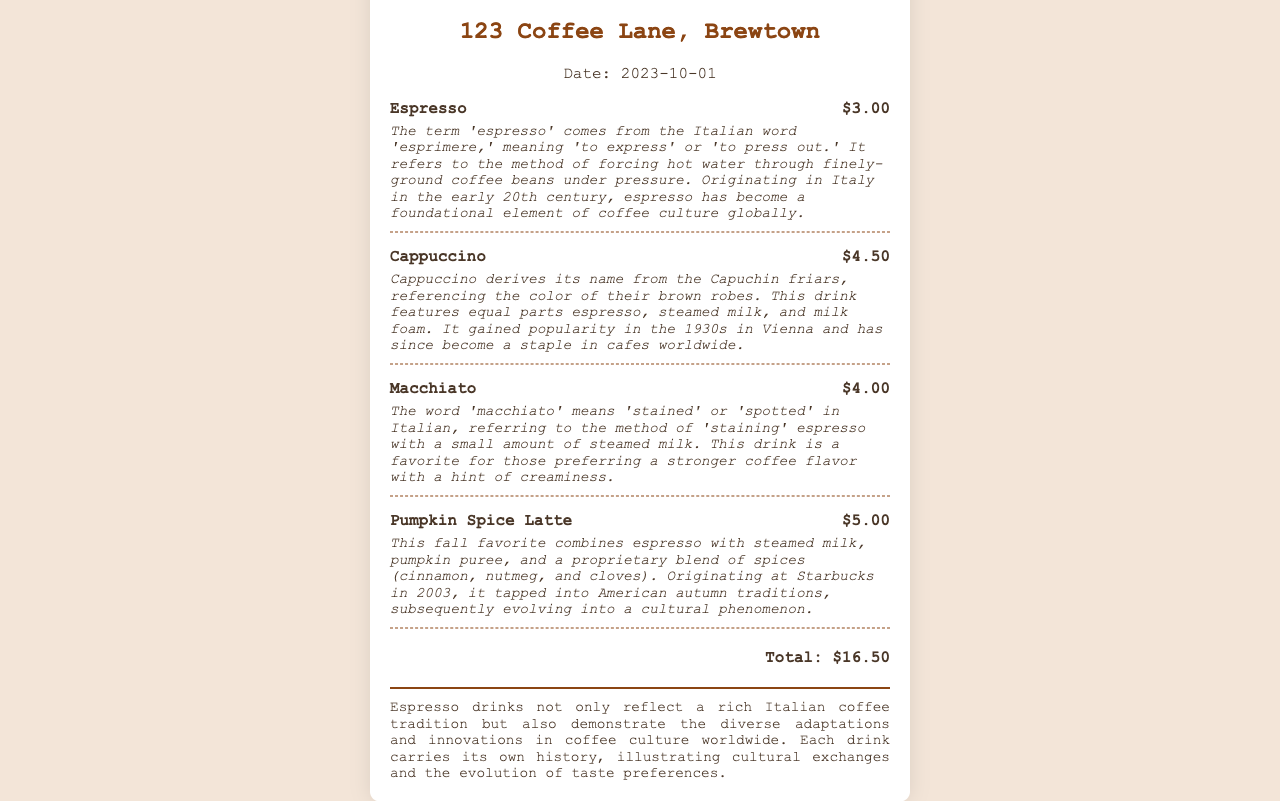What is the date of the receipt? The date of the receipt is clearly stated at the top of the document.
Answer: 2023-10-01 What is the total amount on the receipt? The total amount is summarized at the bottom of the receipt.
Answer: $16.50 What drink comes from the Italian word meaning 'to express'? The origin of the word is provided within the description of the drink.
Answer: Espresso Which drink is named after Capuchin friars? The cultural reference is explained in the item's description.
Answer: Cappuccino How much does a Pumpkin Spice Latte cost? The prices are listed next to each item in the receipt.
Answer: $5.00 What does 'macchiato' mean in Italian? The meaning is explained in the description of the macchiato drink.
Answer: Stained In which decade did the Cappuccino gain popularity? The information is found in the drink's origin history on the receipt.
Answer: 1930s What elements are combined in a Pumpkin Spice Latte? The description outlines the ingredients of the drink.
Answer: Espresso, steamed milk, pumpkin puree, and spices What cultural significance do espresso drinks have according to the receipt? The section on cultural significance summarizes the broader context of the drinks.
Answer: Rich Italian coffee tradition and cultural exchanges 